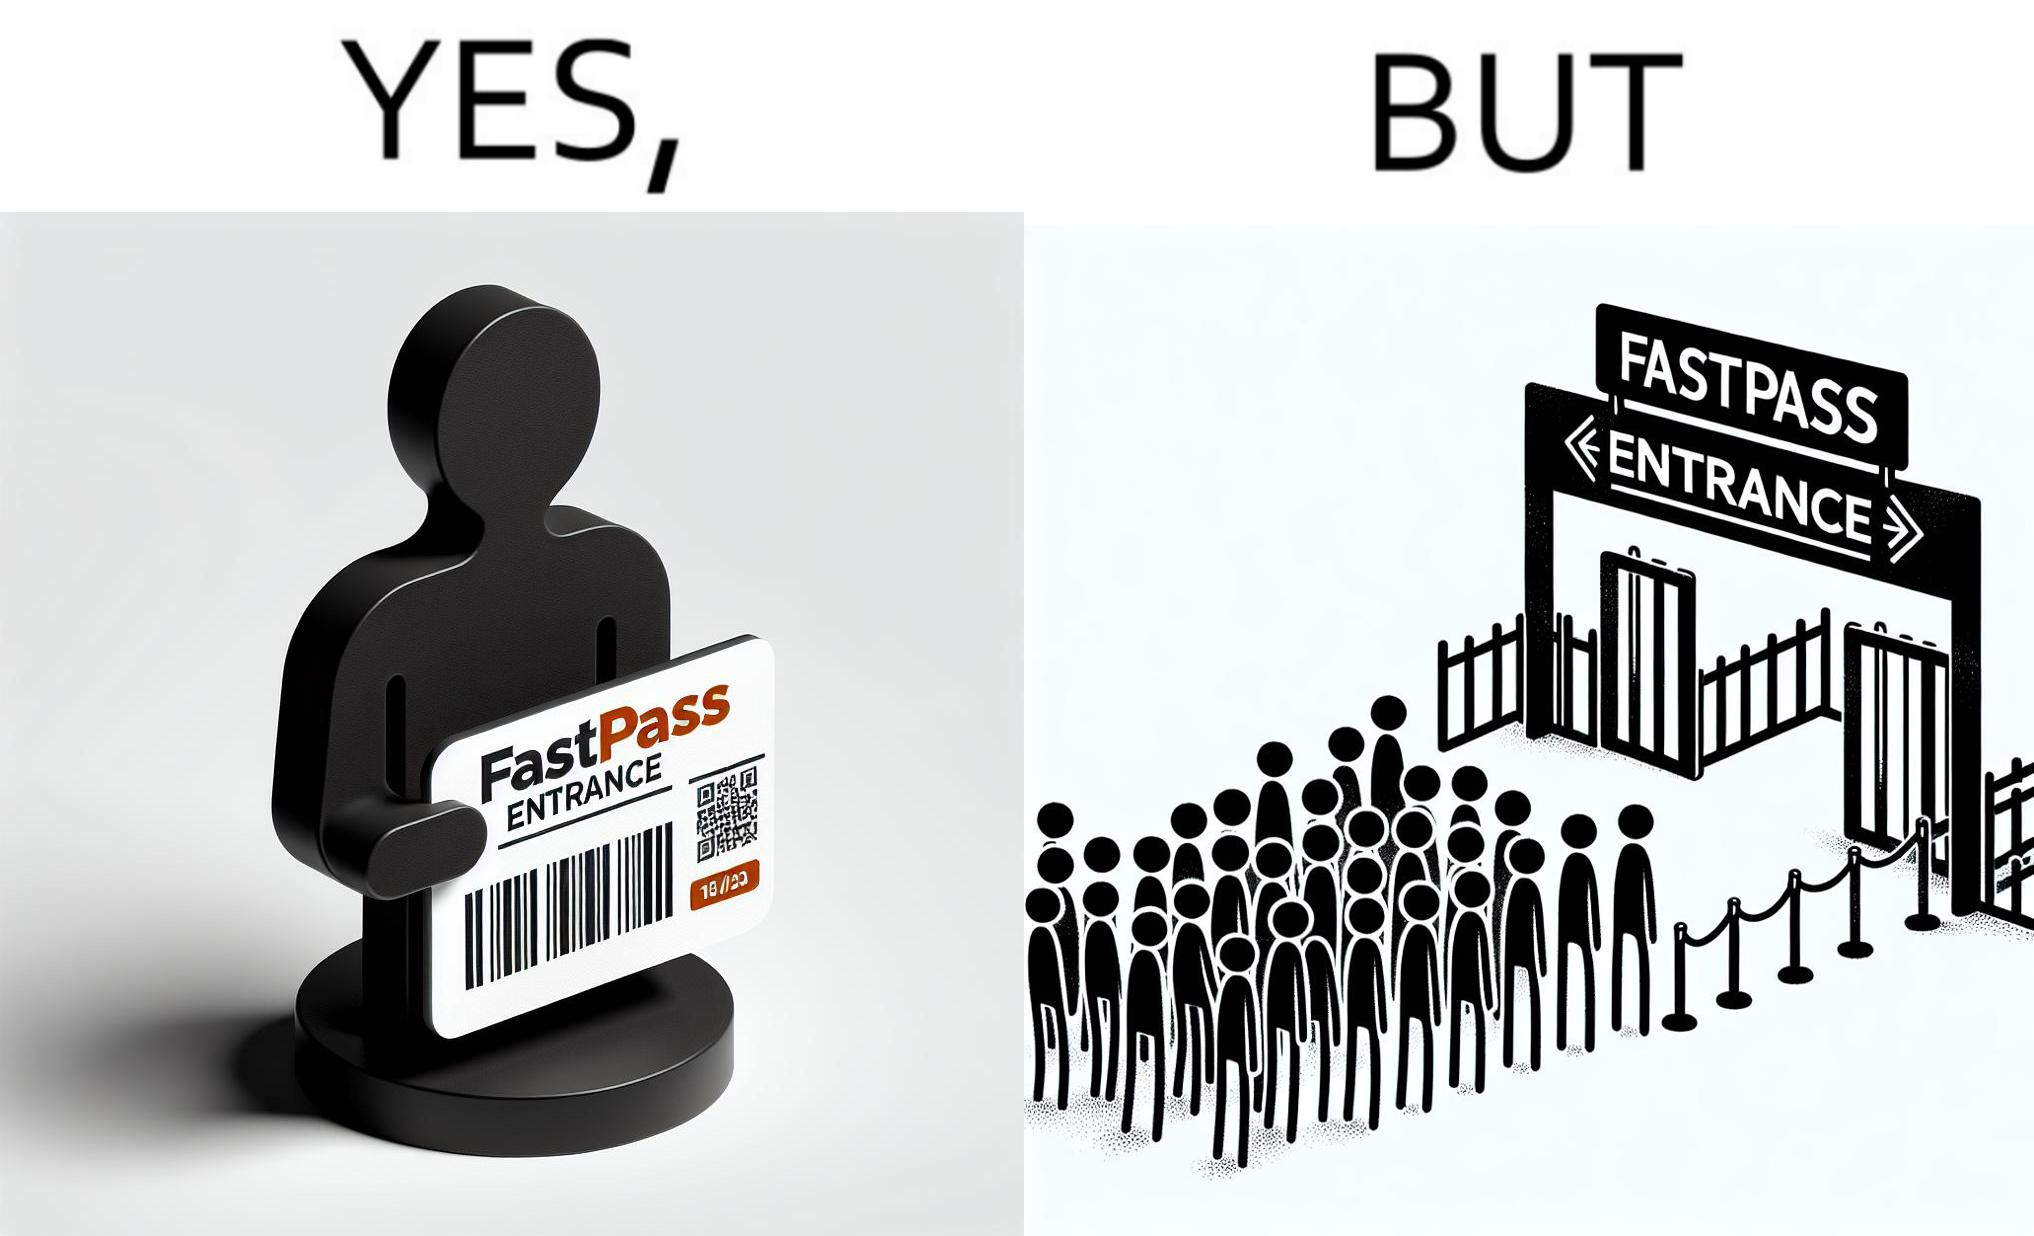What is the satirical meaning behind this image? The image is ironic, because fast pass entrance was meant for people to pass the gate fast but as more no. of people bought the pass due to which the queue has become longer and it becomes slow and time consuming 